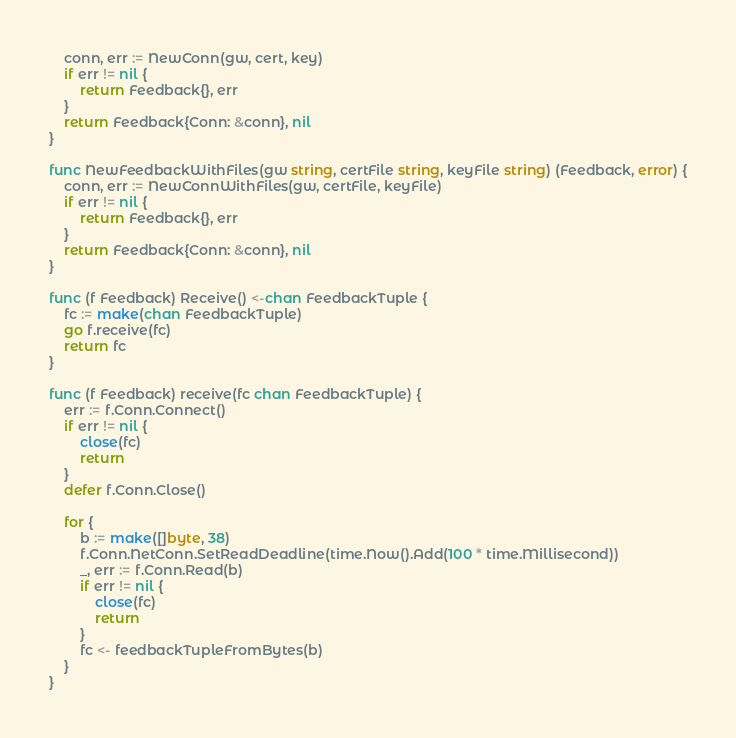Convert code to text. <code><loc_0><loc_0><loc_500><loc_500><_Go_>	conn, err := NewConn(gw, cert, key)
	if err != nil {
		return Feedback{}, err
	}
	return Feedback{Conn: &conn}, nil
}

func NewFeedbackWithFiles(gw string, certFile string, keyFile string) (Feedback, error) {
	conn, err := NewConnWithFiles(gw, certFile, keyFile)
	if err != nil {
		return Feedback{}, err
	}
	return Feedback{Conn: &conn}, nil
}

func (f Feedback) Receive() <-chan FeedbackTuple {
	fc := make(chan FeedbackTuple)
	go f.receive(fc)
	return fc
}

func (f Feedback) receive(fc chan FeedbackTuple) {
	err := f.Conn.Connect()
	if err != nil {
		close(fc)
		return
	}
	defer f.Conn.Close()

	for {
		b := make([]byte, 38)
		f.Conn.NetConn.SetReadDeadline(time.Now().Add(100 * time.Millisecond))
		_, err := f.Conn.Read(b)
		if err != nil {
			close(fc)
			return
		}
		fc <- feedbackTupleFromBytes(b)
	}
}
</code> 